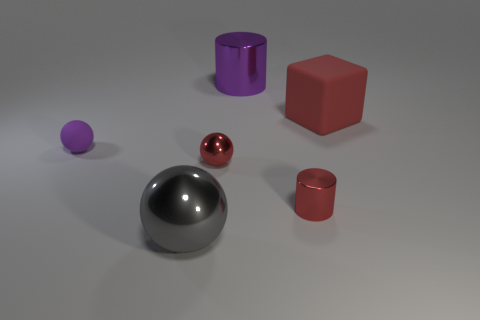Add 2 small gray rubber blocks. How many objects exist? 8 Subtract all metallic spheres. How many spheres are left? 1 Subtract all blocks. How many objects are left? 5 Subtract 1 cylinders. How many cylinders are left? 1 Subtract all brown blocks. Subtract all blue spheres. How many blocks are left? 1 Subtract all green cylinders. How many purple cubes are left? 0 Subtract all small matte balls. Subtract all big gray spheres. How many objects are left? 4 Add 3 small metallic things. How many small metallic things are left? 5 Add 4 rubber spheres. How many rubber spheres exist? 5 Subtract all purple balls. How many balls are left? 2 